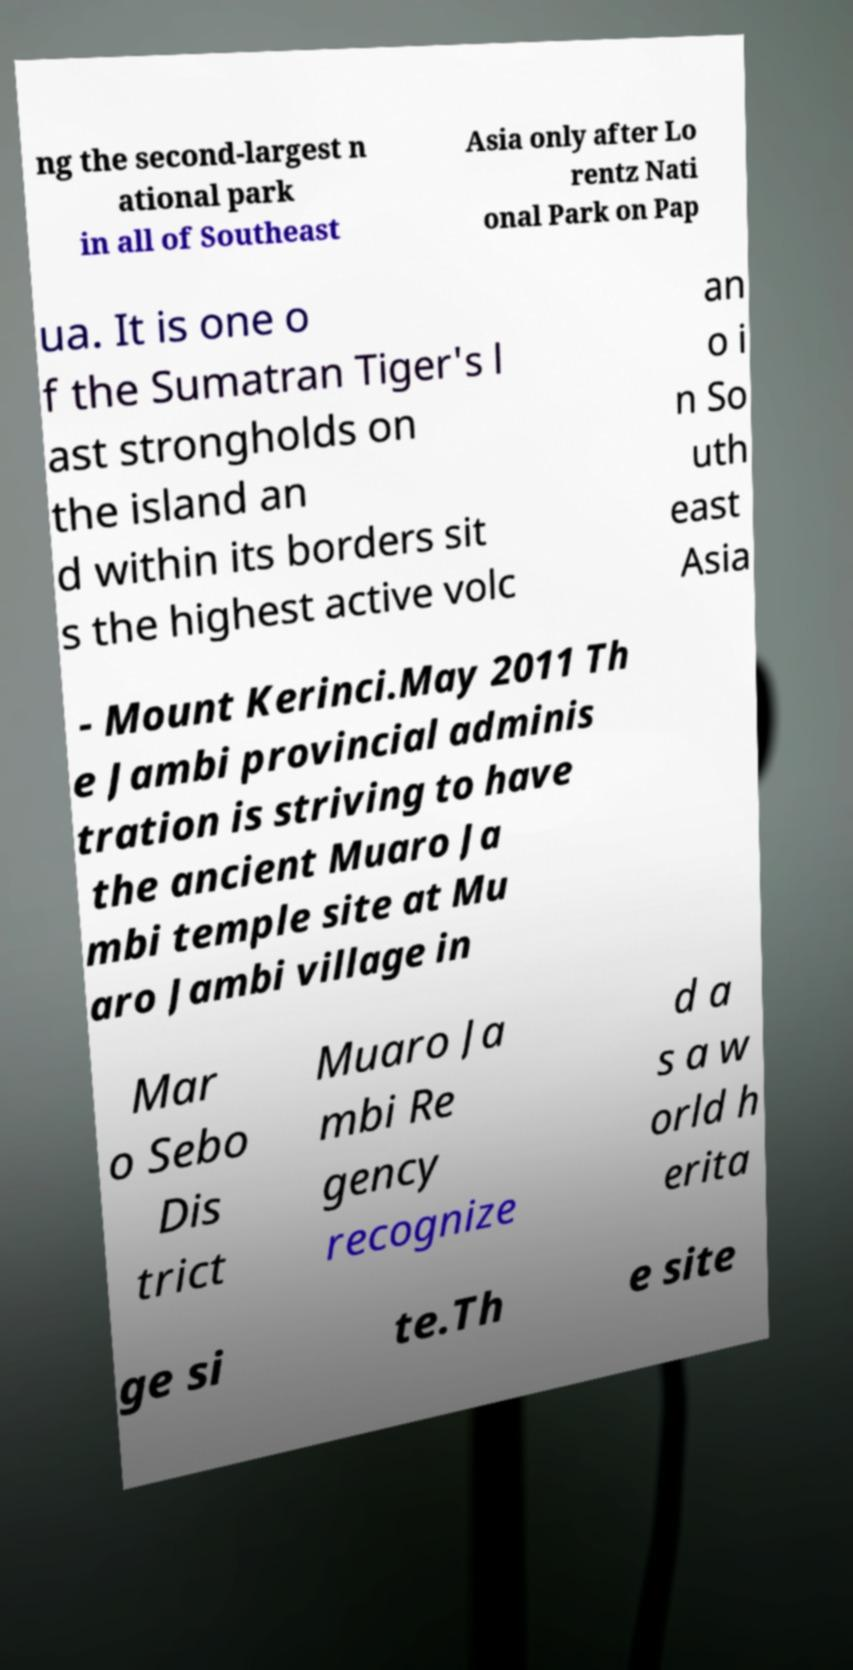Can you accurately transcribe the text from the provided image for me? ng the second-largest n ational park in all of Southeast Asia only after Lo rentz Nati onal Park on Pap ua. It is one o f the Sumatran Tiger's l ast strongholds on the island an d within its borders sit s the highest active volc an o i n So uth east Asia - Mount Kerinci.May 2011 Th e Jambi provincial adminis tration is striving to have the ancient Muaro Ja mbi temple site at Mu aro Jambi village in Mar o Sebo Dis trict Muaro Ja mbi Re gency recognize d a s a w orld h erita ge si te.Th e site 